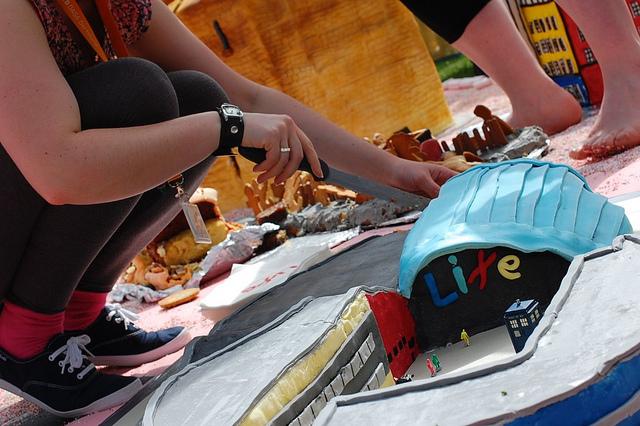What is this a sculpture of?
Write a very short answer. Building. Are both people wearing shoes?
Quick response, please. No. What is the word on the blue sculpture?
Short answer required. Lite. 